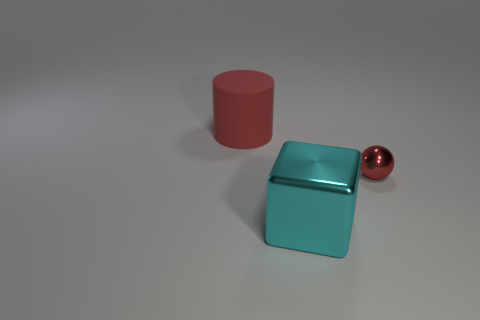Add 3 cubes. How many objects exist? 6 Subtract all balls. How many objects are left? 2 Add 1 small red metal spheres. How many small red metal spheres are left? 2 Add 3 red objects. How many red objects exist? 5 Subtract 0 purple blocks. How many objects are left? 3 Subtract all large blocks. Subtract all purple cubes. How many objects are left? 2 